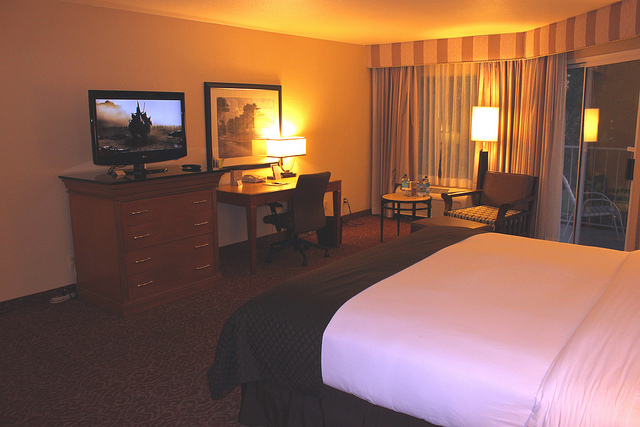<image>What is on the TV? I don't know what is on the TV. It can be seen 'ship', 'movie' 'horse' or 'train'. What is on the TV? I am not sure what is on the TV. It can be seen a ship, navy ship, program, movie, horse or train. 